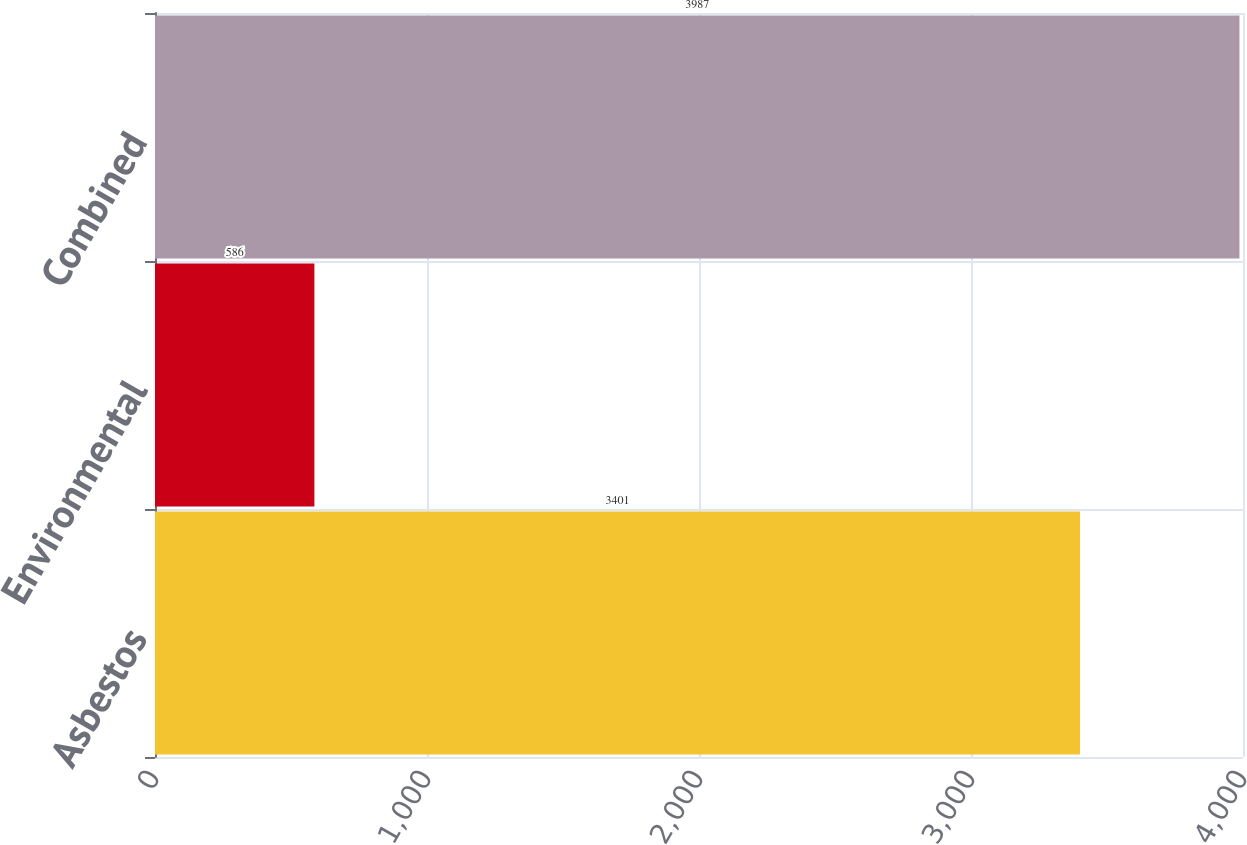Convert chart to OTSL. <chart><loc_0><loc_0><loc_500><loc_500><bar_chart><fcel>Asbestos<fcel>Environmental<fcel>Combined<nl><fcel>3401<fcel>586<fcel>3987<nl></chart> 